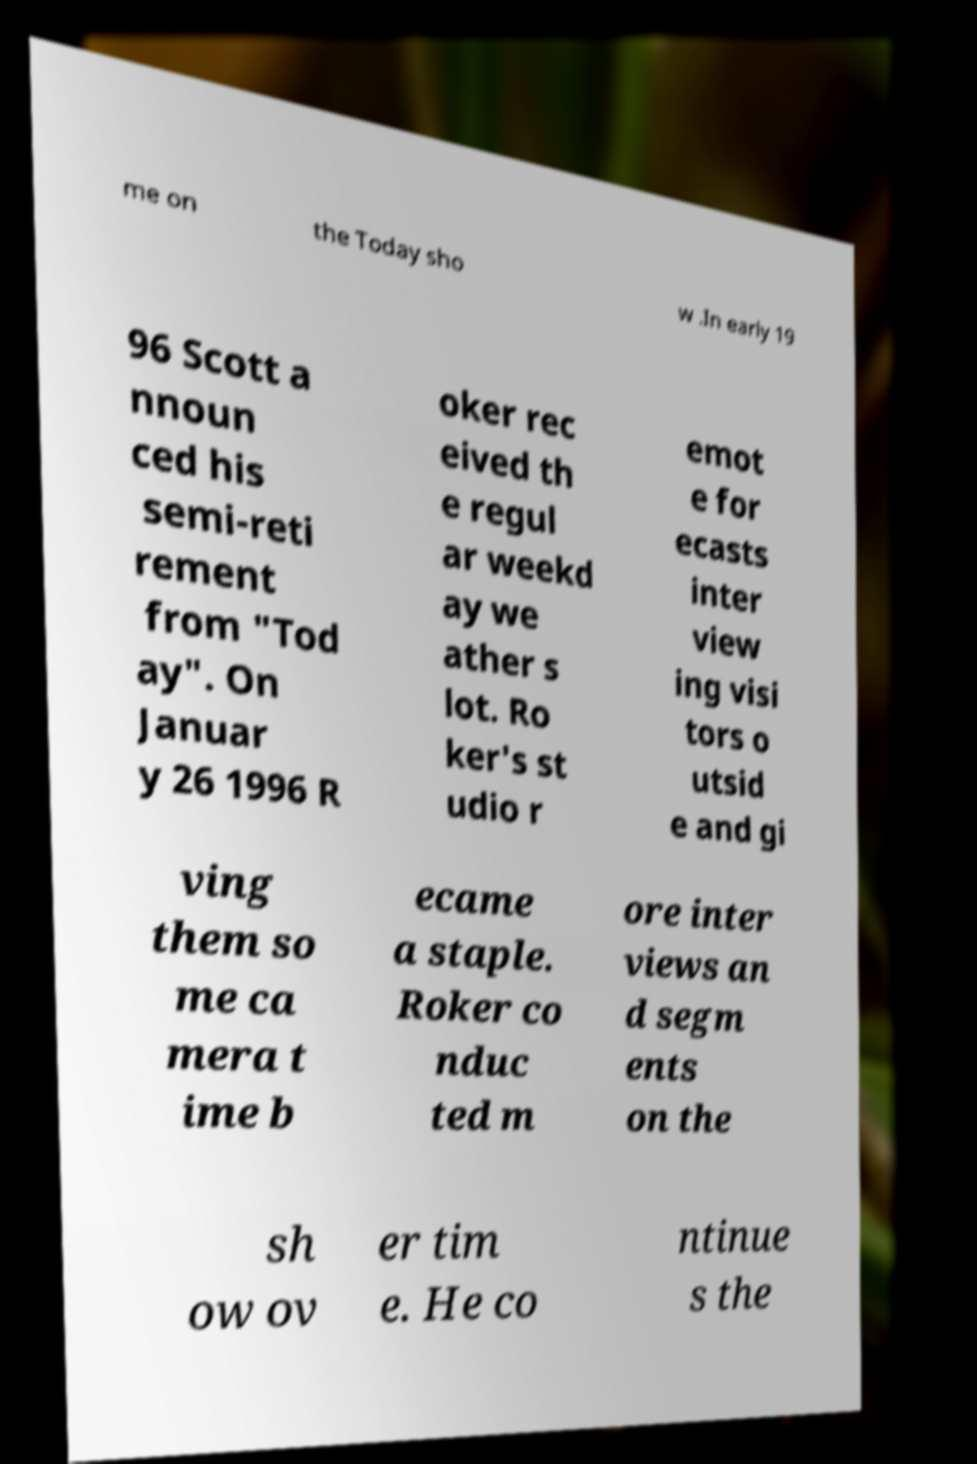I need the written content from this picture converted into text. Can you do that? me on the Today sho w .In early 19 96 Scott a nnoun ced his semi-reti rement from "Tod ay". On Januar y 26 1996 R oker rec eived th e regul ar weekd ay we ather s lot. Ro ker's st udio r emot e for ecasts inter view ing visi tors o utsid e and gi ving them so me ca mera t ime b ecame a staple. Roker co nduc ted m ore inter views an d segm ents on the sh ow ov er tim e. He co ntinue s the 